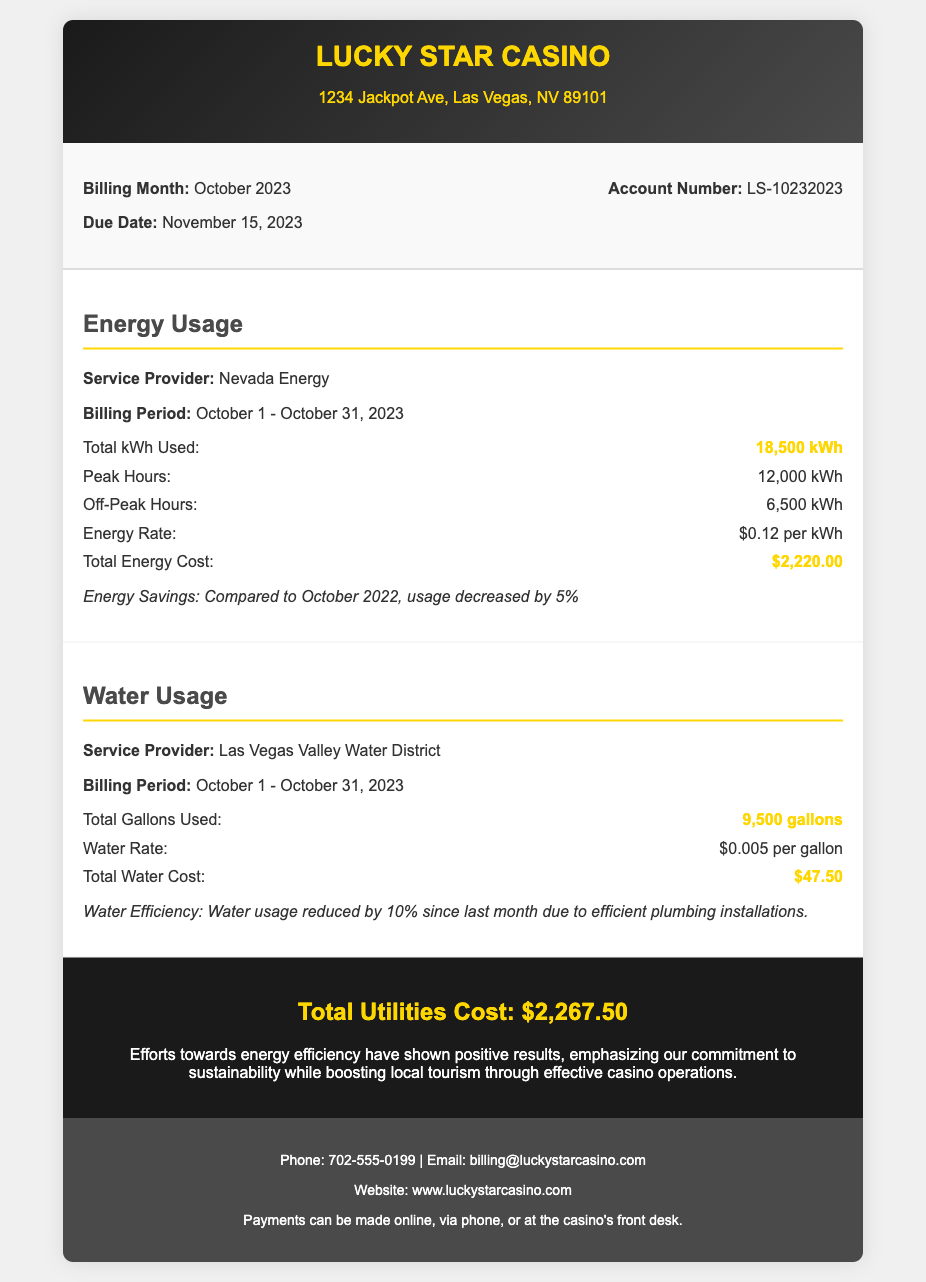What is the total energy usage for October 2023? The total energy usage is provided as "Total kWh Used" in the document, which is 18,500 kWh.
Answer: 18,500 kWh What is the due date for the utility bill? The due date is clearly stated in the document as November 15, 2023.
Answer: November 15, 2023 What is the total water used for the month? The document lists "Total Gallons Used" under water usage as 9,500 gallons.
Answer: 9,500 gallons What was the total energy cost? The total energy cost is indicated as the "Total Energy Cost" in the document, amounting to $2,220.00.
Answer: $2,220.00 How much did water usage reduce since last month? The document states a reduction of 10% in water usage due to efficient plumbing installations.
Answer: 10% What is the account number for the utility bill? The account number is displayed in the billing information section as LS-10232023.
Answer: LS-10232023 What is the total utilities cost? The document summarizes the overall utilities cost at the bottom under "Total Utilities Cost," which is $2,267.50.
Answer: $2,267.50 What is the service provider for water? The service provider for water usage is clearly stated in the document as Las Vegas Valley Water District.
Answer: Las Vegas Valley Water District What was the peak energy usage? The peak energy usage is listed as "Peak Hours" in the document, which is 12,000 kWh.
Answer: 12,000 kWh 